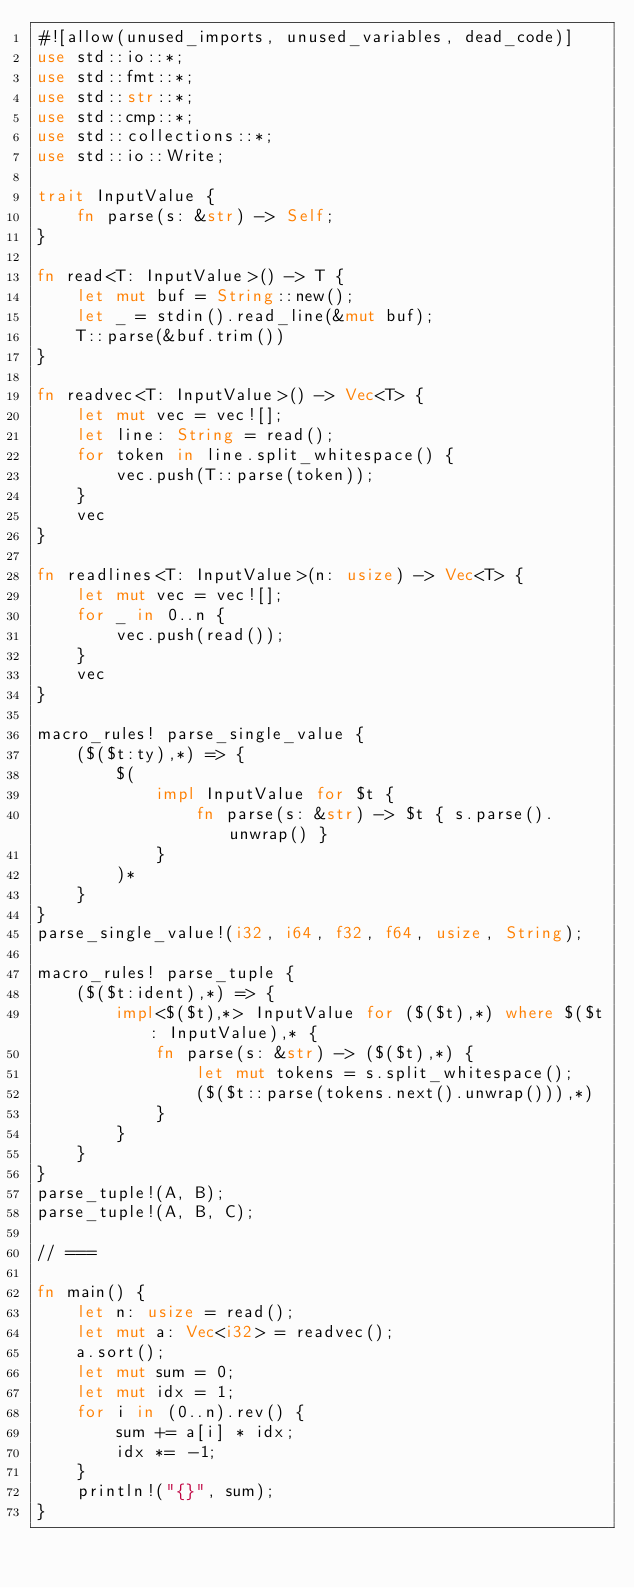<code> <loc_0><loc_0><loc_500><loc_500><_Rust_>#![allow(unused_imports, unused_variables, dead_code)]
use std::io::*;
use std::fmt::*;
use std::str::*;
use std::cmp::*;
use std::collections::*;
use std::io::Write;

trait InputValue {
    fn parse(s: &str) -> Self;
}

fn read<T: InputValue>() -> T {
    let mut buf = String::new();
    let _ = stdin().read_line(&mut buf);
    T::parse(&buf.trim())
}

fn readvec<T: InputValue>() -> Vec<T> {
    let mut vec = vec![];
    let line: String = read();
    for token in line.split_whitespace() {
        vec.push(T::parse(token));
    }
    vec
}

fn readlines<T: InputValue>(n: usize) -> Vec<T> {
    let mut vec = vec![];
    for _ in 0..n {
        vec.push(read());
    }
    vec
}

macro_rules! parse_single_value {
    ($($t:ty),*) => {
        $(
            impl InputValue for $t {
                fn parse(s: &str) -> $t { s.parse().unwrap() }
            }
        )*
    }
}
parse_single_value!(i32, i64, f32, f64, usize, String);

macro_rules! parse_tuple {
    ($($t:ident),*) => {
        impl<$($t),*> InputValue for ($($t),*) where $($t: InputValue),* {
            fn parse(s: &str) -> ($($t),*) {
                let mut tokens = s.split_whitespace();
                ($($t::parse(tokens.next().unwrap())),*)
            }
        }
    }
}
parse_tuple!(A, B);
parse_tuple!(A, B, C);

// ===

fn main() {
    let n: usize = read();
    let mut a: Vec<i32> = readvec();
    a.sort();
    let mut sum = 0;
    let mut idx = 1;
    for i in (0..n).rev() {
        sum += a[i] * idx;
        idx *= -1;
    }
    println!("{}", sum);
}</code> 